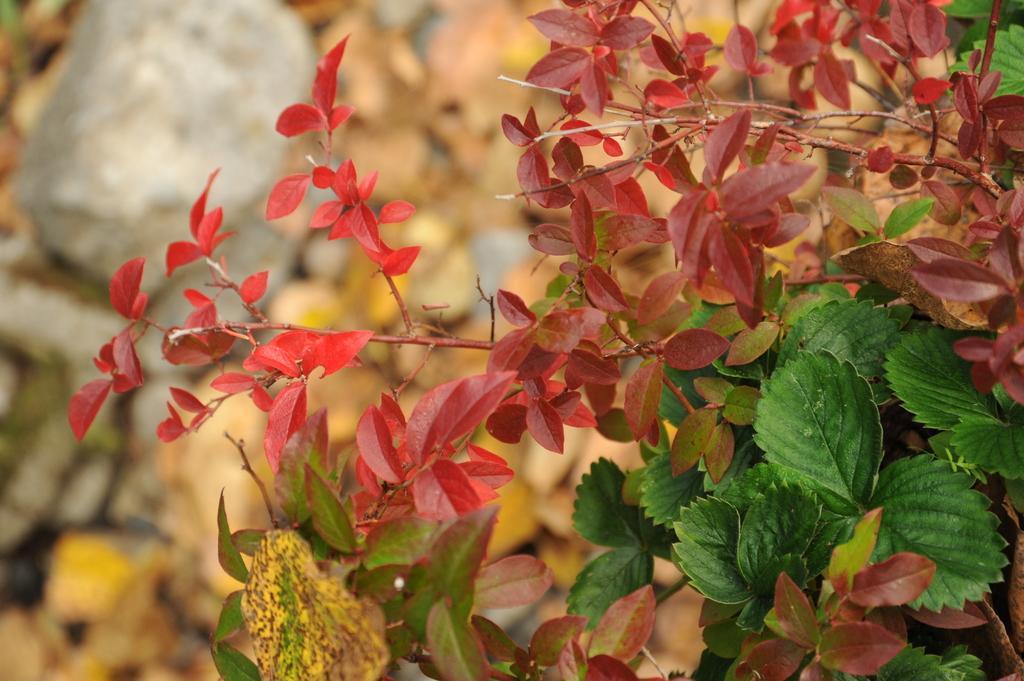Can you describe this image briefly? In the image there are plants all over the land, on the left side background there is a rock. 